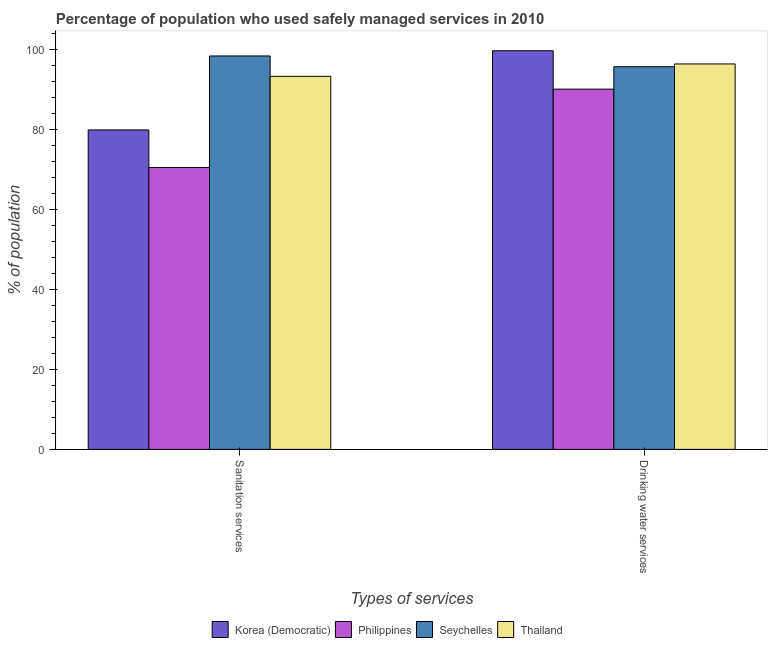How many different coloured bars are there?
Offer a very short reply. 4. How many groups of bars are there?
Your answer should be compact. 2. Are the number of bars on each tick of the X-axis equal?
Provide a succinct answer. Yes. How many bars are there on the 1st tick from the right?
Make the answer very short. 4. What is the label of the 2nd group of bars from the left?
Your answer should be compact. Drinking water services. What is the percentage of population who used drinking water services in Korea (Democratic)?
Offer a terse response. 99.7. Across all countries, what is the maximum percentage of population who used drinking water services?
Provide a short and direct response. 99.7. Across all countries, what is the minimum percentage of population who used sanitation services?
Keep it short and to the point. 70.5. In which country was the percentage of population who used sanitation services maximum?
Offer a terse response. Seychelles. What is the total percentage of population who used drinking water services in the graph?
Keep it short and to the point. 381.9. What is the difference between the percentage of population who used sanitation services in Thailand and that in Korea (Democratic)?
Your answer should be compact. 13.4. What is the difference between the percentage of population who used sanitation services in Thailand and the percentage of population who used drinking water services in Korea (Democratic)?
Keep it short and to the point. -6.4. What is the average percentage of population who used sanitation services per country?
Offer a terse response. 85.53. What is the difference between the percentage of population who used drinking water services and percentage of population who used sanitation services in Korea (Democratic)?
Make the answer very short. 19.8. In how many countries, is the percentage of population who used sanitation services greater than 76 %?
Offer a very short reply. 3. What is the ratio of the percentage of population who used sanitation services in Philippines to that in Thailand?
Give a very brief answer. 0.76. In how many countries, is the percentage of population who used sanitation services greater than the average percentage of population who used sanitation services taken over all countries?
Offer a very short reply. 2. What does the 4th bar from the left in Drinking water services represents?
Your response must be concise. Thailand. What does the 4th bar from the right in Drinking water services represents?
Your response must be concise. Korea (Democratic). How many countries are there in the graph?
Make the answer very short. 4. Does the graph contain any zero values?
Give a very brief answer. No. How many legend labels are there?
Give a very brief answer. 4. How are the legend labels stacked?
Keep it short and to the point. Horizontal. What is the title of the graph?
Your answer should be very brief. Percentage of population who used safely managed services in 2010. Does "Gabon" appear as one of the legend labels in the graph?
Ensure brevity in your answer.  No. What is the label or title of the X-axis?
Your answer should be very brief. Types of services. What is the label or title of the Y-axis?
Ensure brevity in your answer.  % of population. What is the % of population of Korea (Democratic) in Sanitation services?
Give a very brief answer. 79.9. What is the % of population in Philippines in Sanitation services?
Give a very brief answer. 70.5. What is the % of population in Seychelles in Sanitation services?
Offer a terse response. 98.4. What is the % of population of Thailand in Sanitation services?
Make the answer very short. 93.3. What is the % of population of Korea (Democratic) in Drinking water services?
Provide a succinct answer. 99.7. What is the % of population of Philippines in Drinking water services?
Provide a short and direct response. 90.1. What is the % of population of Seychelles in Drinking water services?
Provide a succinct answer. 95.7. What is the % of population of Thailand in Drinking water services?
Your answer should be compact. 96.4. Across all Types of services, what is the maximum % of population in Korea (Democratic)?
Your answer should be compact. 99.7. Across all Types of services, what is the maximum % of population in Philippines?
Provide a short and direct response. 90.1. Across all Types of services, what is the maximum % of population of Seychelles?
Your answer should be compact. 98.4. Across all Types of services, what is the maximum % of population in Thailand?
Your answer should be compact. 96.4. Across all Types of services, what is the minimum % of population of Korea (Democratic)?
Give a very brief answer. 79.9. Across all Types of services, what is the minimum % of population of Philippines?
Your answer should be very brief. 70.5. Across all Types of services, what is the minimum % of population of Seychelles?
Provide a succinct answer. 95.7. Across all Types of services, what is the minimum % of population in Thailand?
Offer a terse response. 93.3. What is the total % of population in Korea (Democratic) in the graph?
Give a very brief answer. 179.6. What is the total % of population in Philippines in the graph?
Give a very brief answer. 160.6. What is the total % of population of Seychelles in the graph?
Provide a succinct answer. 194.1. What is the total % of population of Thailand in the graph?
Make the answer very short. 189.7. What is the difference between the % of population in Korea (Democratic) in Sanitation services and that in Drinking water services?
Provide a short and direct response. -19.8. What is the difference between the % of population of Philippines in Sanitation services and that in Drinking water services?
Your answer should be compact. -19.6. What is the difference between the % of population of Seychelles in Sanitation services and that in Drinking water services?
Provide a short and direct response. 2.7. What is the difference between the % of population in Thailand in Sanitation services and that in Drinking water services?
Provide a succinct answer. -3.1. What is the difference between the % of population of Korea (Democratic) in Sanitation services and the % of population of Philippines in Drinking water services?
Offer a terse response. -10.2. What is the difference between the % of population of Korea (Democratic) in Sanitation services and the % of population of Seychelles in Drinking water services?
Keep it short and to the point. -15.8. What is the difference between the % of population of Korea (Democratic) in Sanitation services and the % of population of Thailand in Drinking water services?
Offer a very short reply. -16.5. What is the difference between the % of population in Philippines in Sanitation services and the % of population in Seychelles in Drinking water services?
Ensure brevity in your answer.  -25.2. What is the difference between the % of population in Philippines in Sanitation services and the % of population in Thailand in Drinking water services?
Your answer should be very brief. -25.9. What is the difference between the % of population in Seychelles in Sanitation services and the % of population in Thailand in Drinking water services?
Your response must be concise. 2. What is the average % of population in Korea (Democratic) per Types of services?
Provide a short and direct response. 89.8. What is the average % of population of Philippines per Types of services?
Provide a succinct answer. 80.3. What is the average % of population of Seychelles per Types of services?
Ensure brevity in your answer.  97.05. What is the average % of population of Thailand per Types of services?
Your response must be concise. 94.85. What is the difference between the % of population of Korea (Democratic) and % of population of Seychelles in Sanitation services?
Your response must be concise. -18.5. What is the difference between the % of population of Philippines and % of population of Seychelles in Sanitation services?
Offer a very short reply. -27.9. What is the difference between the % of population in Philippines and % of population in Thailand in Sanitation services?
Your answer should be very brief. -22.8. What is the difference between the % of population of Korea (Democratic) and % of population of Philippines in Drinking water services?
Make the answer very short. 9.6. What is the difference between the % of population of Korea (Democratic) and % of population of Seychelles in Drinking water services?
Offer a terse response. 4. What is the difference between the % of population of Philippines and % of population of Seychelles in Drinking water services?
Offer a very short reply. -5.6. What is the ratio of the % of population in Korea (Democratic) in Sanitation services to that in Drinking water services?
Ensure brevity in your answer.  0.8. What is the ratio of the % of population of Philippines in Sanitation services to that in Drinking water services?
Your response must be concise. 0.78. What is the ratio of the % of population in Seychelles in Sanitation services to that in Drinking water services?
Provide a short and direct response. 1.03. What is the ratio of the % of population of Thailand in Sanitation services to that in Drinking water services?
Offer a terse response. 0.97. What is the difference between the highest and the second highest % of population in Korea (Democratic)?
Ensure brevity in your answer.  19.8. What is the difference between the highest and the second highest % of population of Philippines?
Offer a very short reply. 19.6. What is the difference between the highest and the second highest % of population in Seychelles?
Keep it short and to the point. 2.7. What is the difference between the highest and the lowest % of population in Korea (Democratic)?
Your answer should be compact. 19.8. What is the difference between the highest and the lowest % of population in Philippines?
Your response must be concise. 19.6. 